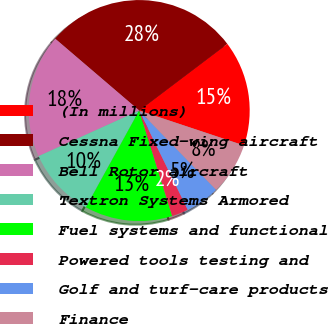Convert chart. <chart><loc_0><loc_0><loc_500><loc_500><pie_chart><fcel>(In millions)<fcel>Cessna Fixed-wing aircraft<fcel>Bell Rotor aircraft<fcel>Textron Systems Armored<fcel>Fuel systems and functional<fcel>Powered tools testing and<fcel>Golf and turf-care products<fcel>Finance<nl><fcel>15.43%<fcel>28.43%<fcel>18.03%<fcel>10.22%<fcel>12.83%<fcel>2.42%<fcel>5.02%<fcel>7.62%<nl></chart> 